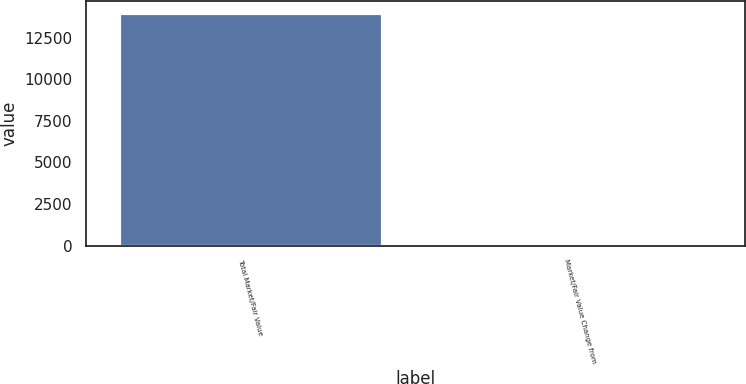<chart> <loc_0><loc_0><loc_500><loc_500><bar_chart><fcel>Total Market/Fair Value<fcel>Market/Fair Value Change from<nl><fcel>13986.6<fcel>5.6<nl></chart> 